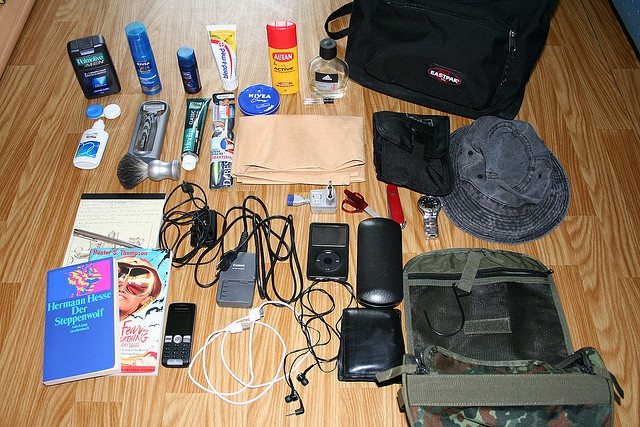Describe the objects in this image and their specific colors. I can see dining table in darkgray, brown, gray, tan, and maroon tones, handbag in darkgray, black, and gray tones, handbag in darkgray, black, maroon, and brown tones, backpack in darkgray, black, maroon, and brown tones, and book in darkgray, blue, gray, and white tones in this image. 